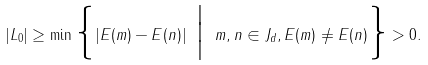Convert formula to latex. <formula><loc_0><loc_0><loc_500><loc_500>| L _ { 0 } | \geq \min \Big \{ | E ( m ) - E ( n ) | \ \Big | \ m , n \in J _ { d } , E ( m ) \neq E ( n ) \Big \} > 0 .</formula> 